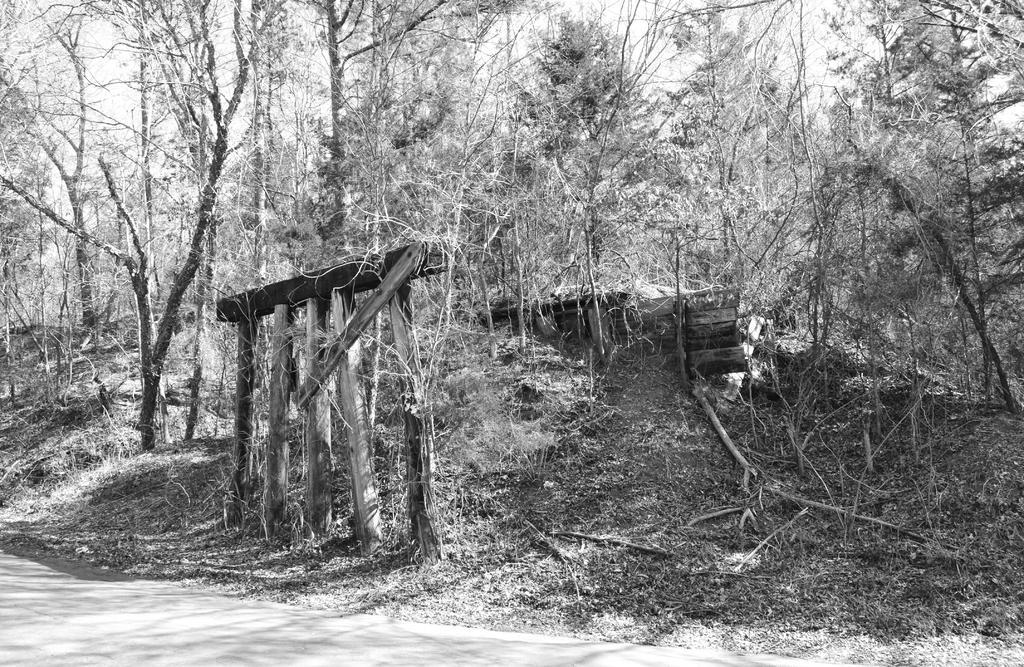In one or two sentences, can you explain what this image depicts? This is a black and white picture. In this picture we can see trees. This is a road. 